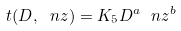<formula> <loc_0><loc_0><loc_500><loc_500>t ( D , \ n z ) = K _ { 5 } D ^ { a } \ n z ^ { b }</formula> 